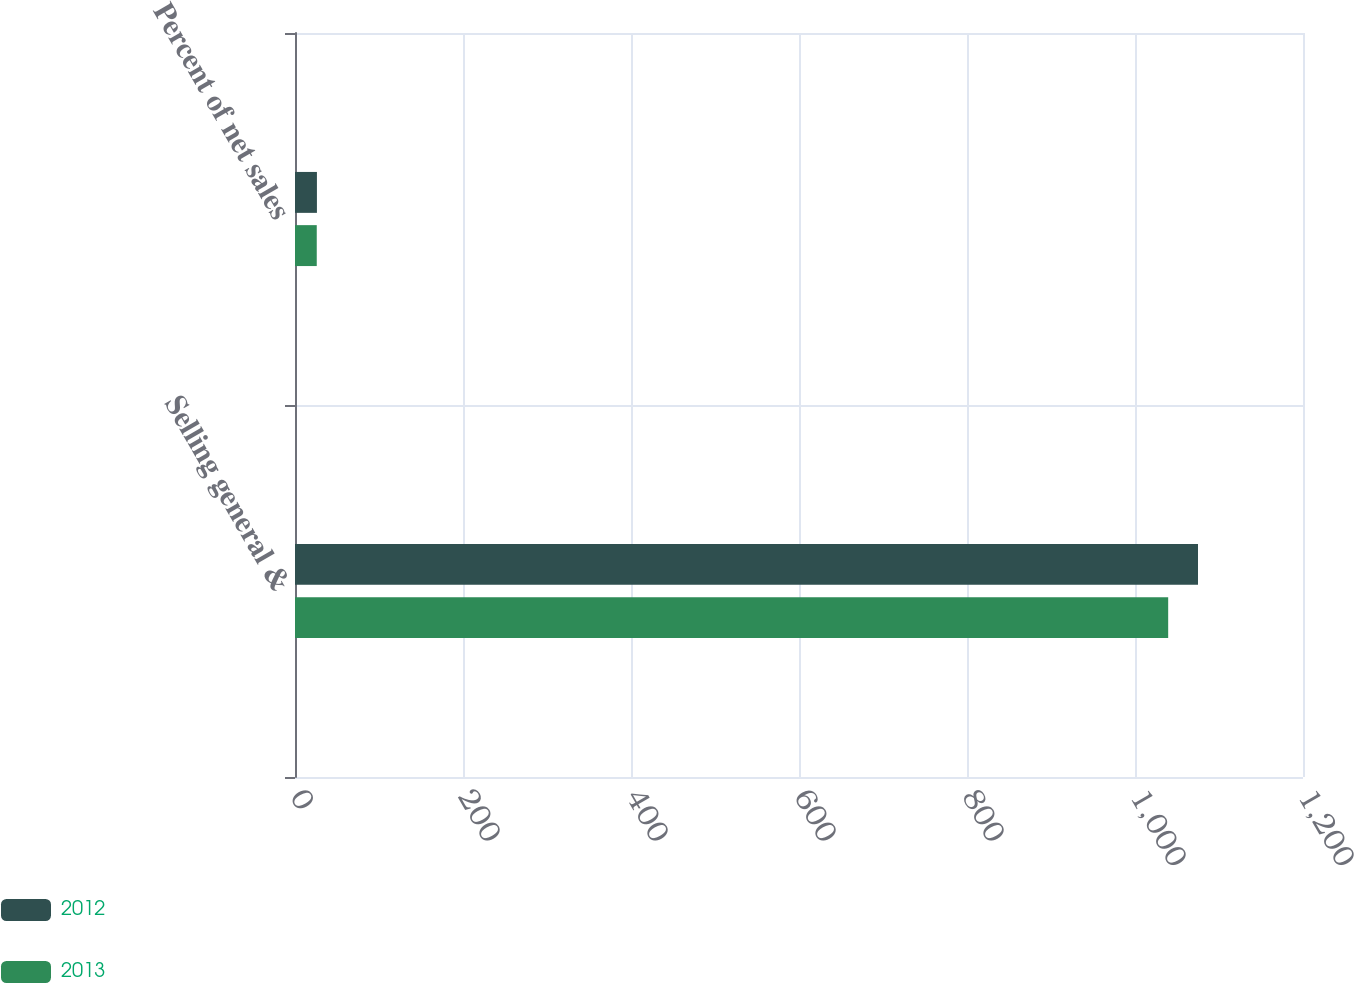Convert chart to OTSL. <chart><loc_0><loc_0><loc_500><loc_500><stacked_bar_chart><ecel><fcel>Selling general &<fcel>Percent of net sales<nl><fcel>2012<fcel>1075<fcel>26.1<nl><fcel>2013<fcel>1039.5<fcel>25.9<nl></chart> 